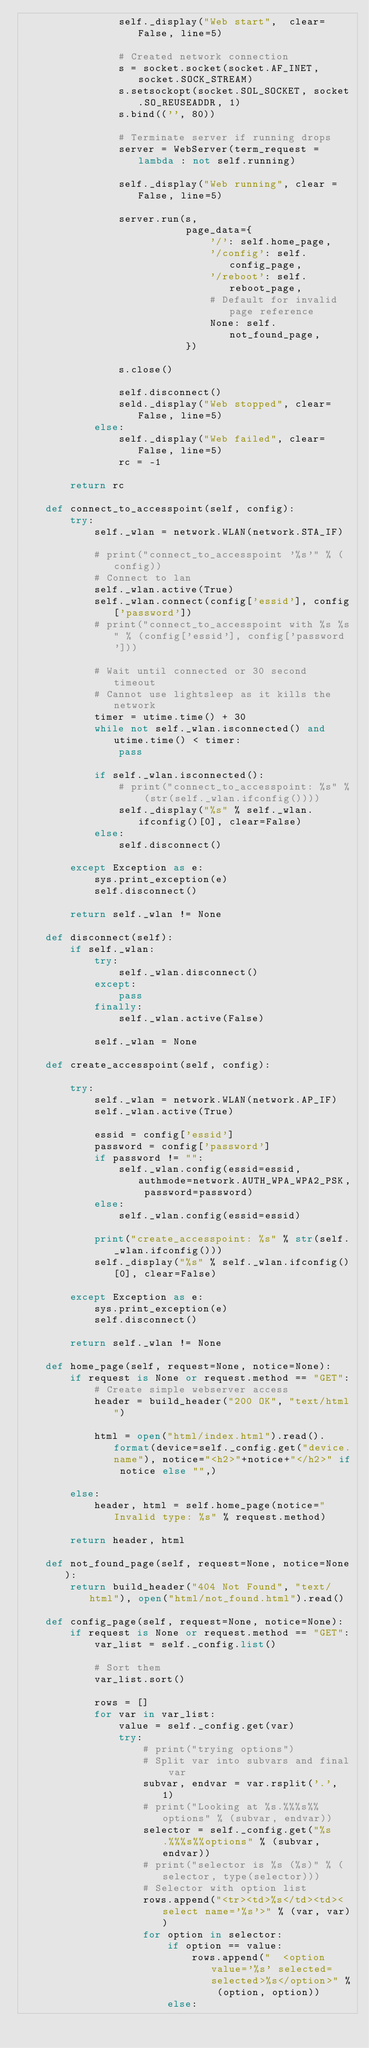Convert code to text. <code><loc_0><loc_0><loc_500><loc_500><_Python_>                self._display("Web start",  clear=False, line=5)

                # Created network connection
                s = socket.socket(socket.AF_INET, socket.SOCK_STREAM)
                s.setsockopt(socket.SOL_SOCKET, socket.SO_REUSEADDR, 1)
                s.bind(('', 80))

                # Terminate server if running drops
                server = WebServer(term_request = lambda : not self.running)

                self._display("Web running", clear = False, line=5)

                server.run(s,
                           page_data={
                               '/': self.home_page,
                               '/config': self.config_page,
                               '/reboot': self.reboot_page,
                               # Default for invalid page reference
                               None: self.not_found_page,
                           })
                    
                s.close()

                self.disconnect()
                seld._display("Web stopped", clear=False, line=5)
            else:
                self._display("Web failed", clear=False, line=5)
                rc = -1

        return rc

    def connect_to_accesspoint(self, config):
        try:
            self._wlan = network.WLAN(network.STA_IF)

            # print("connect_to_accesspoint '%s'" % (config))
            # Connect to lan
            self._wlan.active(True)
            self._wlan.connect(config['essid'], config['password'])
            # print("connect_to_accesspoint with %s %s" % (config['essid'], config['password']))
    
            # Wait until connected or 30 second timeout
            # Cannot use lightsleep as it kills the network
            timer = utime.time() + 30
            while not self._wlan.isconnected() and utime.time() < timer:
                pass
    
            if self._wlan.isconnected():
                # print("connect_to_accesspoint: %s" % (str(self._wlan.ifconfig())))
                self._display("%s" % self._wlan.ifconfig()[0], clear=False)
            else:
                self.disconnect()

        except Exception as e:
            sys.print_exception(e)
            self.disconnect()

        return self._wlan != None

    def disconnect(self):
        if self._wlan:
            try:
                self._wlan.disconnect()
            except:
                pass
            finally:
                self._wlan.active(False)

            self._wlan = None

    def create_accesspoint(self, config):

        try:
            self._wlan = network.WLAN(network.AP_IF)
            self._wlan.active(True)

            essid = config['essid']
            password = config['password']
            if password != "":
                self._wlan.config(essid=essid, authmode=network.AUTH_WPA_WPA2_PSK, password=password)
            else:
                self._wlan.config(essid=essid)

            print("create_accesspoint: %s" % str(self._wlan.ifconfig()))
            self._display("%s" % self._wlan.ifconfig()[0], clear=False)

        except Exception as e:
            sys.print_exception(e)
            self.disconnect()

        return self._wlan != None

    def home_page(self, request=None, notice=None):
        if request is None or request.method == "GET":
            # Create simple webserver access
            header = build_header("200 OK", "text/html")
    
            html = open("html/index.html").read().format(device=self._config.get("device.name"), notice="<h2>"+notice+"</h2>" if notice else "",)
    
        else:
            header, html = self.home_page(notice="Invalid type: %s" % request.method)
    
        return header, html
    
    def not_found_page(self, request=None, notice=None):
        return build_header("404 Not Found", "text/html"), open("html/not_found.html").read()

    def config_page(self, request=None, notice=None):
        if request is None or request.method == "GET":
            var_list = self._config.list()
    
            # Sort them
            var_list.sort()
    
            rows = []
            for var in var_list:
                value = self._config.get(var)
                try:
                    # print("trying options")
                    # Split var into subvars and final var
                    subvar, endvar = var.rsplit('.', 1)
                    # print("Looking at %s.%%%s%%options" % (subvar, endvar))
                    selector = self._config.get("%s.%%%s%%options" % (subvar, endvar))
                    # print("selector is %s (%s)" % (selector, type(selector)))
                    # Selector with option list
                    rows.append("<tr><td>%s</td><td><select name='%s'>" % (var, var))
                    for option in selector:
                        if option == value:
                            rows.append("  <option value='%s' selected=selected>%s</option>" % (option, option))
                        else:</code> 